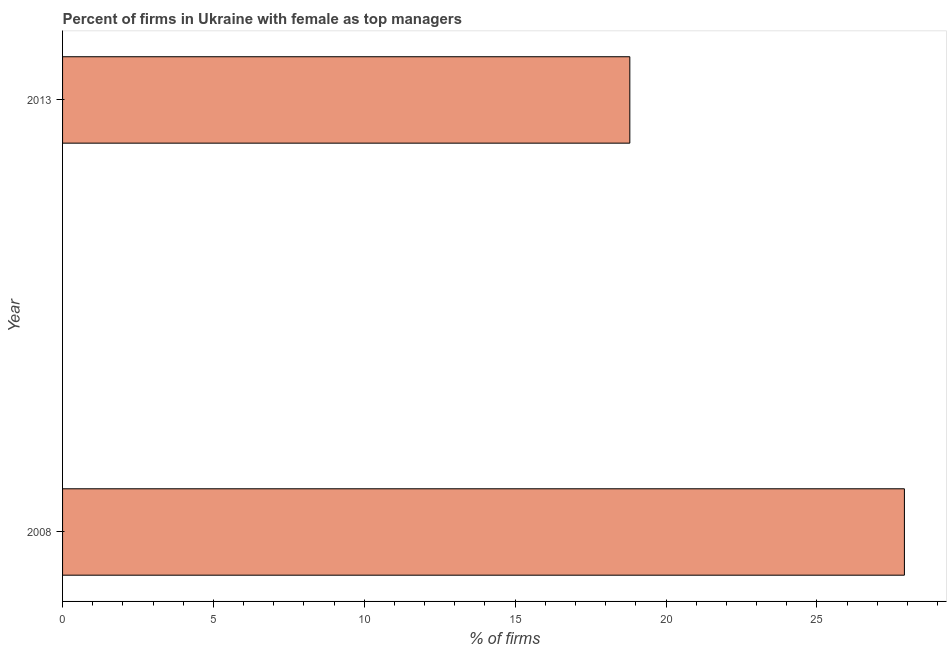Does the graph contain grids?
Make the answer very short. No. What is the title of the graph?
Offer a very short reply. Percent of firms in Ukraine with female as top managers. What is the label or title of the X-axis?
Offer a very short reply. % of firms. What is the label or title of the Y-axis?
Provide a succinct answer. Year. What is the percentage of firms with female as top manager in 2013?
Your answer should be very brief. 18.8. Across all years, what is the maximum percentage of firms with female as top manager?
Your answer should be compact. 27.9. Across all years, what is the minimum percentage of firms with female as top manager?
Offer a very short reply. 18.8. In which year was the percentage of firms with female as top manager maximum?
Your answer should be compact. 2008. In which year was the percentage of firms with female as top manager minimum?
Your answer should be compact. 2013. What is the sum of the percentage of firms with female as top manager?
Offer a very short reply. 46.7. What is the average percentage of firms with female as top manager per year?
Keep it short and to the point. 23.35. What is the median percentage of firms with female as top manager?
Ensure brevity in your answer.  23.35. In how many years, is the percentage of firms with female as top manager greater than 11 %?
Your answer should be very brief. 2. Do a majority of the years between 2008 and 2013 (inclusive) have percentage of firms with female as top manager greater than 15 %?
Offer a terse response. Yes. What is the ratio of the percentage of firms with female as top manager in 2008 to that in 2013?
Give a very brief answer. 1.48. Is the percentage of firms with female as top manager in 2008 less than that in 2013?
Offer a very short reply. No. How many bars are there?
Make the answer very short. 2. What is the difference between two consecutive major ticks on the X-axis?
Provide a succinct answer. 5. What is the % of firms in 2008?
Ensure brevity in your answer.  27.9. What is the difference between the % of firms in 2008 and 2013?
Keep it short and to the point. 9.1. What is the ratio of the % of firms in 2008 to that in 2013?
Keep it short and to the point. 1.48. 